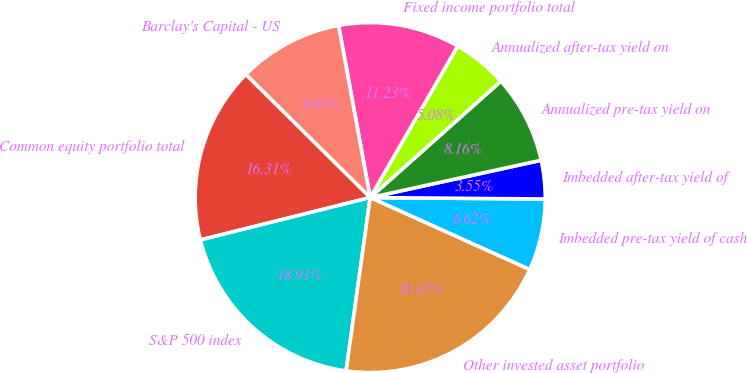Convert chart. <chart><loc_0><loc_0><loc_500><loc_500><pie_chart><fcel>Imbedded pre-tax yield of cash<fcel>Imbedded after-tax yield of<fcel>Annualized pre-tax yield on<fcel>Annualized after-tax yield on<fcel>Fixed income portfolio total<fcel>Barclay's Capital - US<fcel>Common equity portfolio total<fcel>S&P 500 index<fcel>Other invested asset portfolio<nl><fcel>6.62%<fcel>3.55%<fcel>8.16%<fcel>5.08%<fcel>11.23%<fcel>9.69%<fcel>16.31%<fcel>18.91%<fcel>20.45%<nl></chart> 